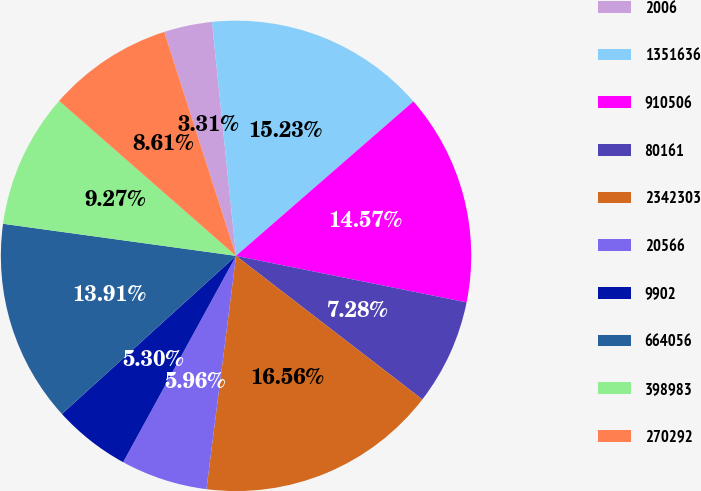Convert chart to OTSL. <chart><loc_0><loc_0><loc_500><loc_500><pie_chart><fcel>2006<fcel>1351636<fcel>910506<fcel>80161<fcel>2342303<fcel>20566<fcel>9902<fcel>664056<fcel>398983<fcel>270292<nl><fcel>3.31%<fcel>15.23%<fcel>14.57%<fcel>7.28%<fcel>16.56%<fcel>5.96%<fcel>5.3%<fcel>13.91%<fcel>9.27%<fcel>8.61%<nl></chart> 